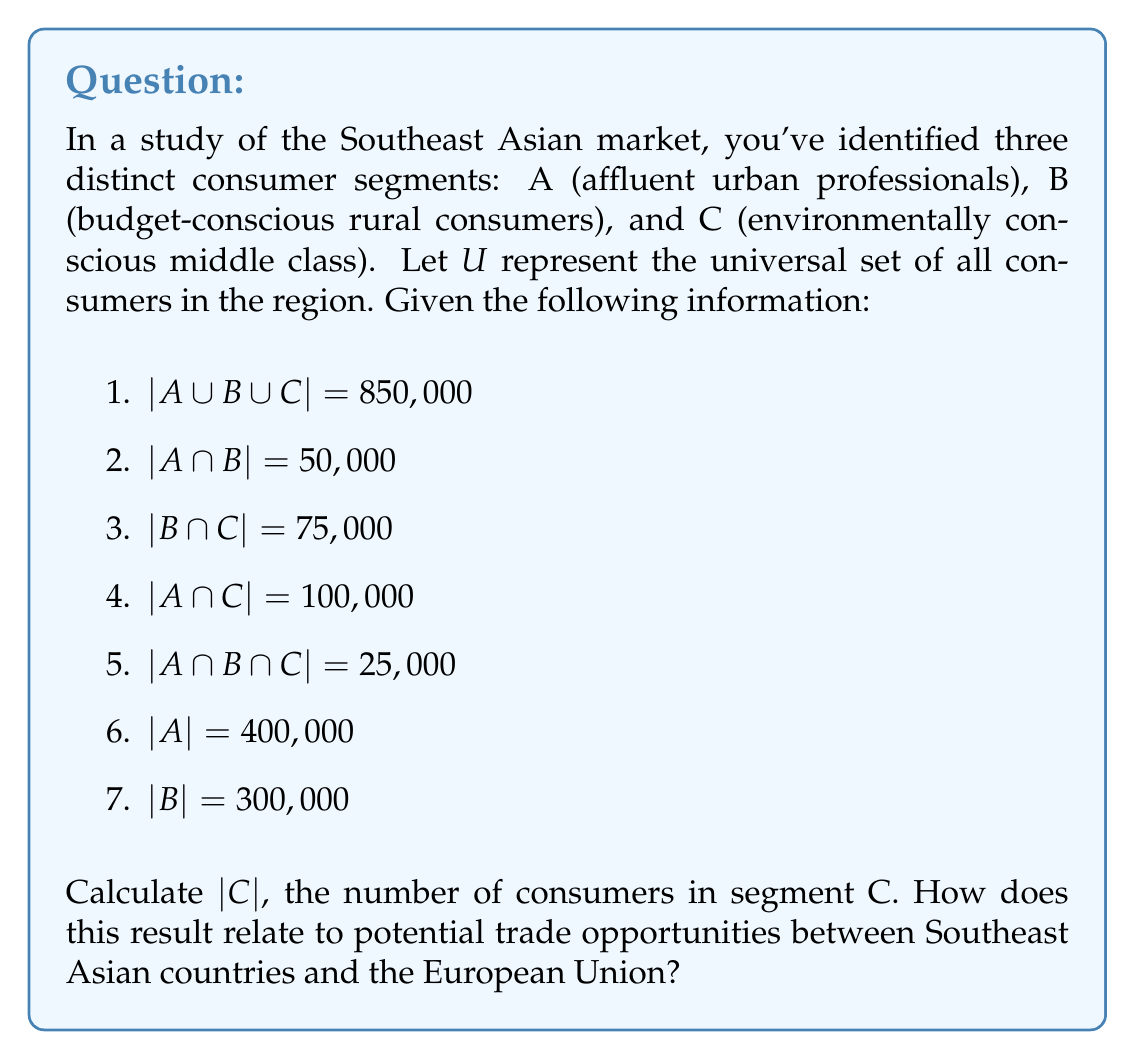Could you help me with this problem? To solve this problem, we'll use the Inclusion-Exclusion Principle from set theory. The principle states that for three sets A, B, and C:

$$|A \cup B \cup C| = |A| + |B| + |C| - |A \cap B| - |A \cap C| - |B \cap C| + |A \cap B \cap C|$$

We're given most of these values, so let's substitute them into the equation:

$$850,000 = 400,000 + 300,000 + |C| - 50,000 - 100,000 - 75,000 + 25,000$$

Now, let's solve for $|C|$:

$$850,000 = 700,000 + |C| - 225,000 + 25,000$$
$$850,000 = 500,000 + |C|$$
$$|C| = 850,000 - 500,000 = 350,000$$

Therefore, the number of consumers in segment C is 350,000.

Relating this to international trade opportunities:

1. Market size: The total market size (850,000 consumers) and the size of each segment provide valuable information for EU companies looking to enter or expand in the Southeast Asian market.

2. Targeted approach: Understanding the size of each segment allows for more targeted marketing and product development strategies. For example, the environmentally conscious middle class (segment C) represents a significant portion of the market, which could be attractive for EU companies with eco-friendly products or services.

3. Trade agreement implications: When negotiating trade agreements between the EU and Southeast Asian countries, policymakers can use this market segmentation data to focus on sectors that align with the largest consumer segments. For instance, given the size of segment C, there might be opportunities to reduce tariffs on environmentally friendly products.

4. Cultural considerations: The segmentation reflects cultural and economic diversity in Southeast Asia, which is crucial for EU businesses to understand when entering the market. This knowledge can inform decisions about product localization and marketing strategies.

5. Economic development: The relatively large size of segment C (environmentally conscious middle class) may indicate growing economic prosperity and changing consumer preferences in the region, which could influence future trade policies and agreements.
Answer: $|C| = 350,000$ consumers

This result indicates a significant market for environmentally conscious products and services in Southeast Asia, which could inform trade negotiations and business strategies for EU companies entering the market. 